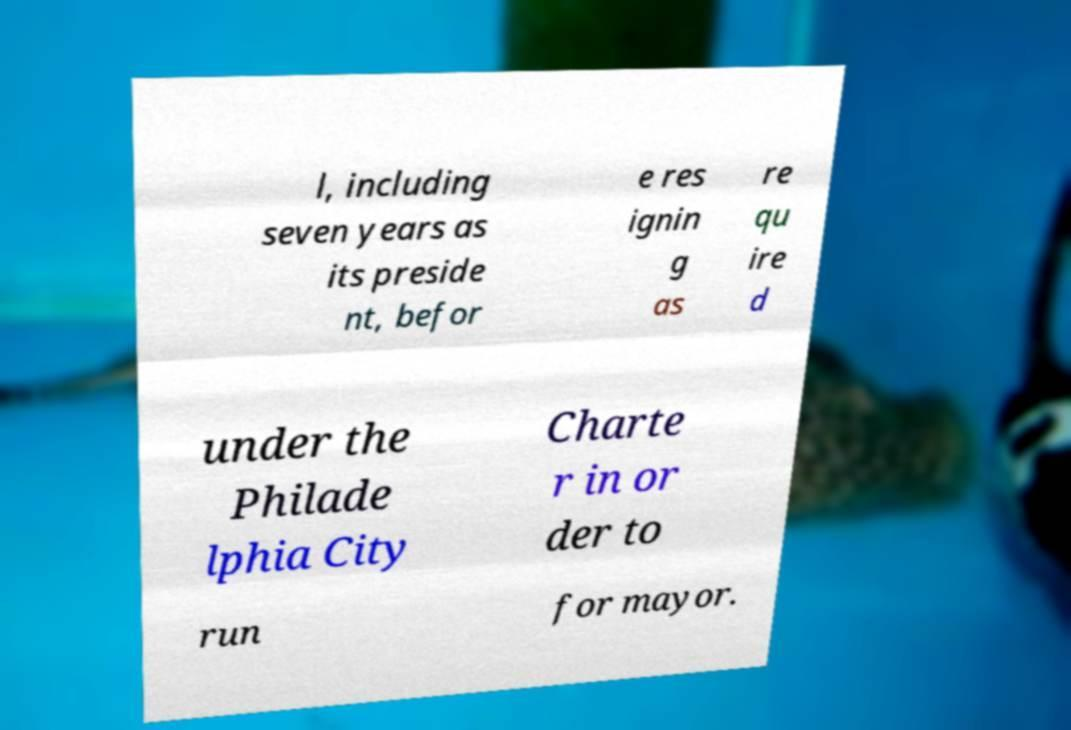Please identify and transcribe the text found in this image. l, including seven years as its preside nt, befor e res ignin g as re qu ire d under the Philade lphia City Charte r in or der to run for mayor. 